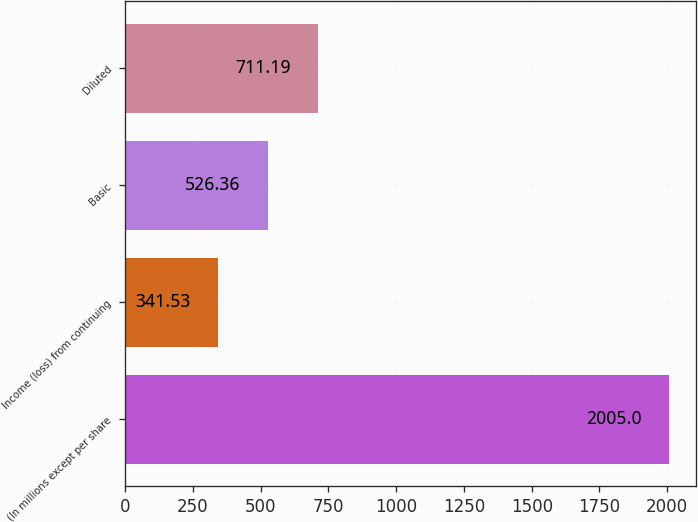Convert chart to OTSL. <chart><loc_0><loc_0><loc_500><loc_500><bar_chart><fcel>(In millions except per share<fcel>Income (loss) from continuing<fcel>Basic<fcel>Diluted<nl><fcel>2005<fcel>341.53<fcel>526.36<fcel>711.19<nl></chart> 